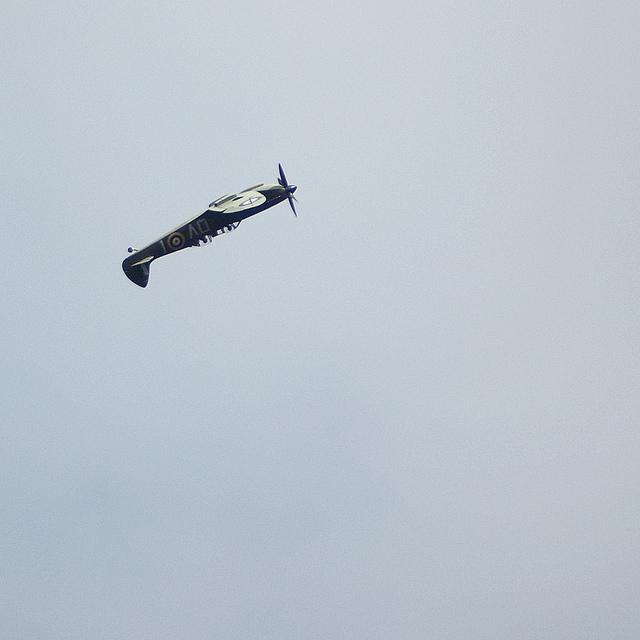Is the landing gear down?
Concise answer only. No. What type of vehicle are the men on?
Short answer required. Plane. What is wrong with this aircraft?
Quick response, please. Upside down. What quadrant of the picture is the propeller closest to?
Short answer required. 1. Is the plane upside down?
Answer briefly. Yes. How many propellers are shown?
Quick response, please. 1. Are they crashing?
Write a very short answer. No. What type of plane is this?
Be succinct. Single engine. Is there a bird in the picture?
Write a very short answer. No. Is this a plane or a helicopter?
Concise answer only. Plane. Is this person snowboarding?
Keep it brief. No. What color is the background?
Be succinct. Blue. Is this plane right side up?
Quick response, please. No. 